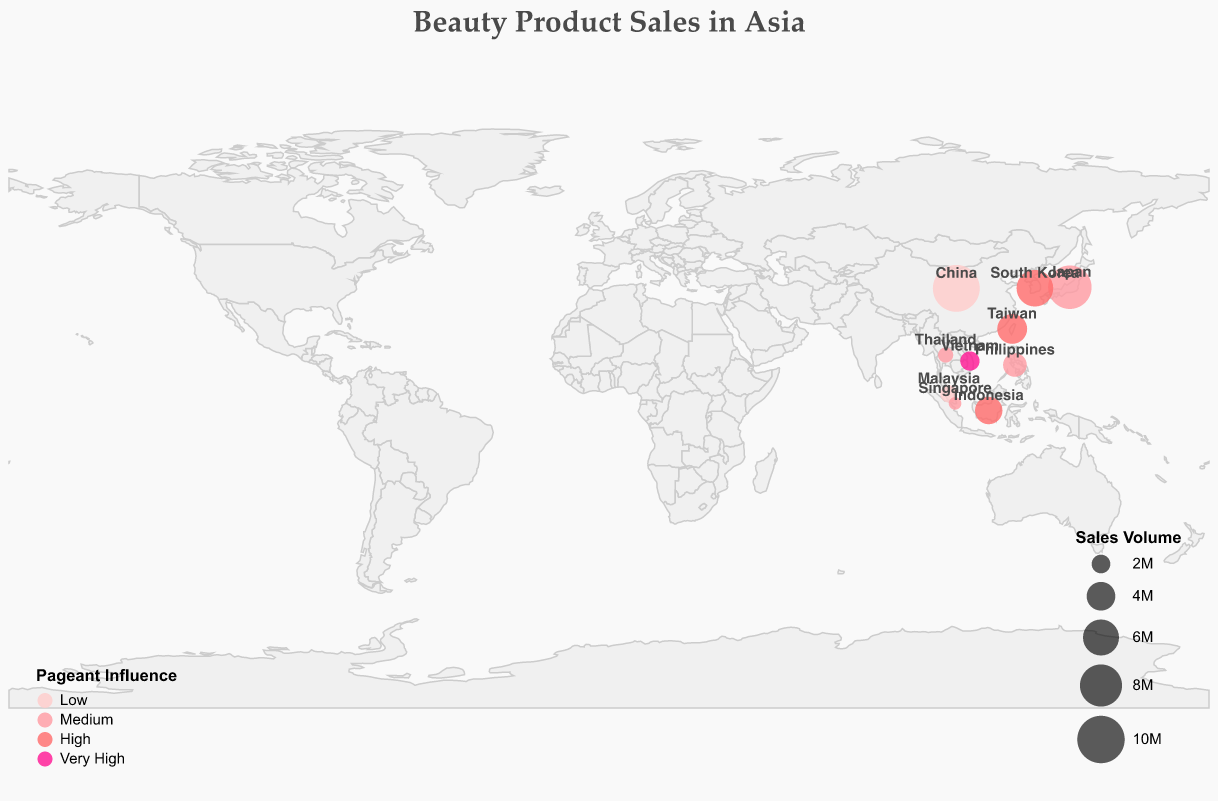Which country has the highest sales volume for beauty products? By looking at the size of the circles, the largest circle corresponds to China with a sales volume of 9,800,000.
Answer: China What is the top brand for makeup in South Korea? The tooltip for South Korea shows that the top brand for makeup is Etude House.
Answer: Etude House How many countries have a "High" pageant influence on beauty product sales? By counting the circles colored in the "High" influence color, which is #ff6b6b (pinkish-red), we find there are four countries: South Korea, Indonesia, and Taiwan.
Answer: 3 What is the combined sales volume of Fragrance and Sun Care product categories? Fragrance sales volume in Vietnam is 2,100,000 and Sun Care sales volume in the Philippines is 2,900,000. Summing these up gives us 2,100,000 + 2,900,000 = 5,000,000.
Answer: 5,000,000 Which country has the lowest sales volume, and what product category is it associated with? By observing the smallest circle, we find that the lowest sales volume is in Singapore with 1,200,000, associated with Eye Makeup.
Answer: Singapore, Eye Makeup Compare the pageant influence on beauty product sales between Japan and Vietnam. Japan has a "Medium" level of pageant influence, while Vietnam has a "Very High" level of pageant influence.
Answer: Japan: Medium, Vietnam: Very High Which beauty product category has the highest sales volume in China? The tooltip for China indicates that the highest sales volume category is Haircare.
Answer: Haircare Which product category has a "Medium" level pageant influence in the Philippines? The tooltip for the Philippines shows that the product category with "Medium" pageant influence is Sun Care.
Answer: Sun Care What's the most popular top brand in Indonesia according to the sales volume data? The tooltip for Indonesia indicates that the top brand is Wardah for Lip Products.
Answer: Wardah What is the sales volume for face masks in Taiwan, and what pageant influence do they have? According to the tooltip for Taiwan, the sales volume for face masks is 4,300,000 and the pageant influence is "High".
Answer: 4,300,000, High 